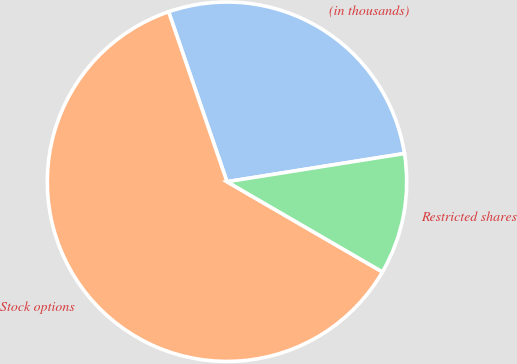<chart> <loc_0><loc_0><loc_500><loc_500><pie_chart><fcel>(in thousands)<fcel>Stock options<fcel>Restricted shares<nl><fcel>27.76%<fcel>61.36%<fcel>10.88%<nl></chart> 